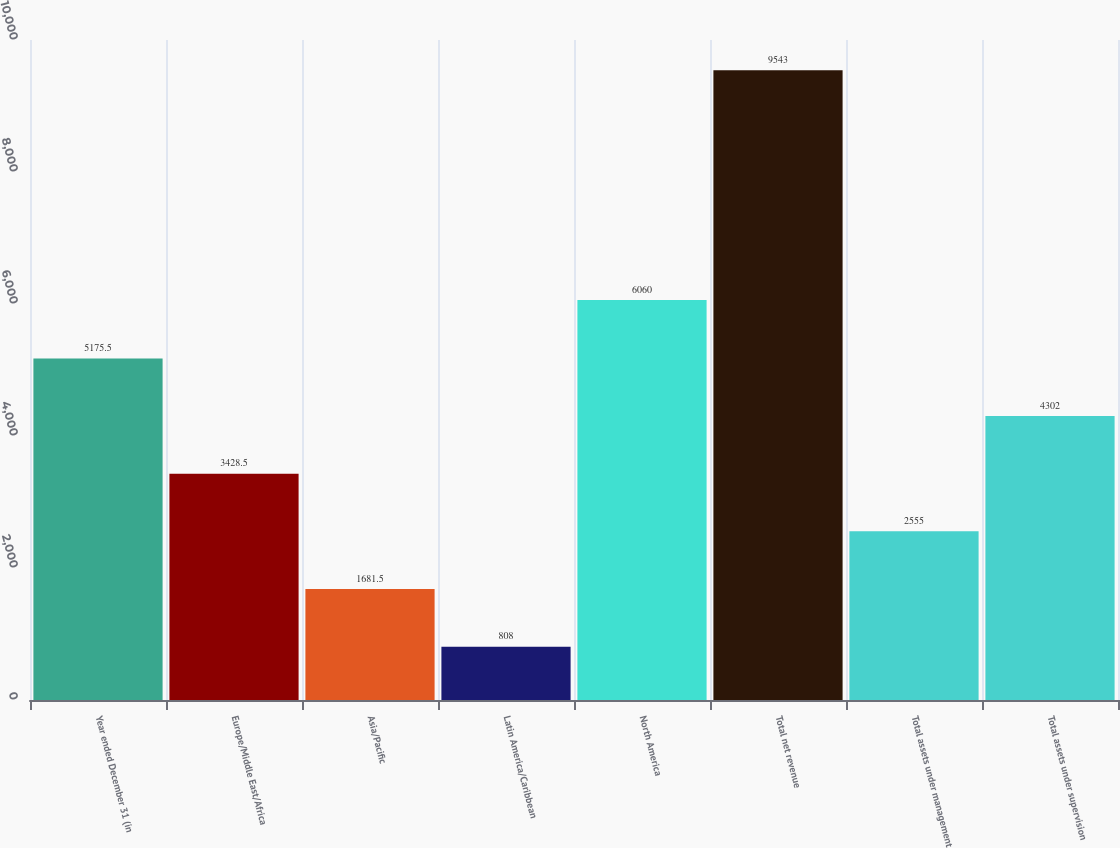Convert chart. <chart><loc_0><loc_0><loc_500><loc_500><bar_chart><fcel>Year ended December 31 (in<fcel>Europe/Middle East/Africa<fcel>Asia/Pacific<fcel>Latin America/Caribbean<fcel>North America<fcel>Total net revenue<fcel>Total assets under management<fcel>Total assets under supervision<nl><fcel>5175.5<fcel>3428.5<fcel>1681.5<fcel>808<fcel>6060<fcel>9543<fcel>2555<fcel>4302<nl></chart> 